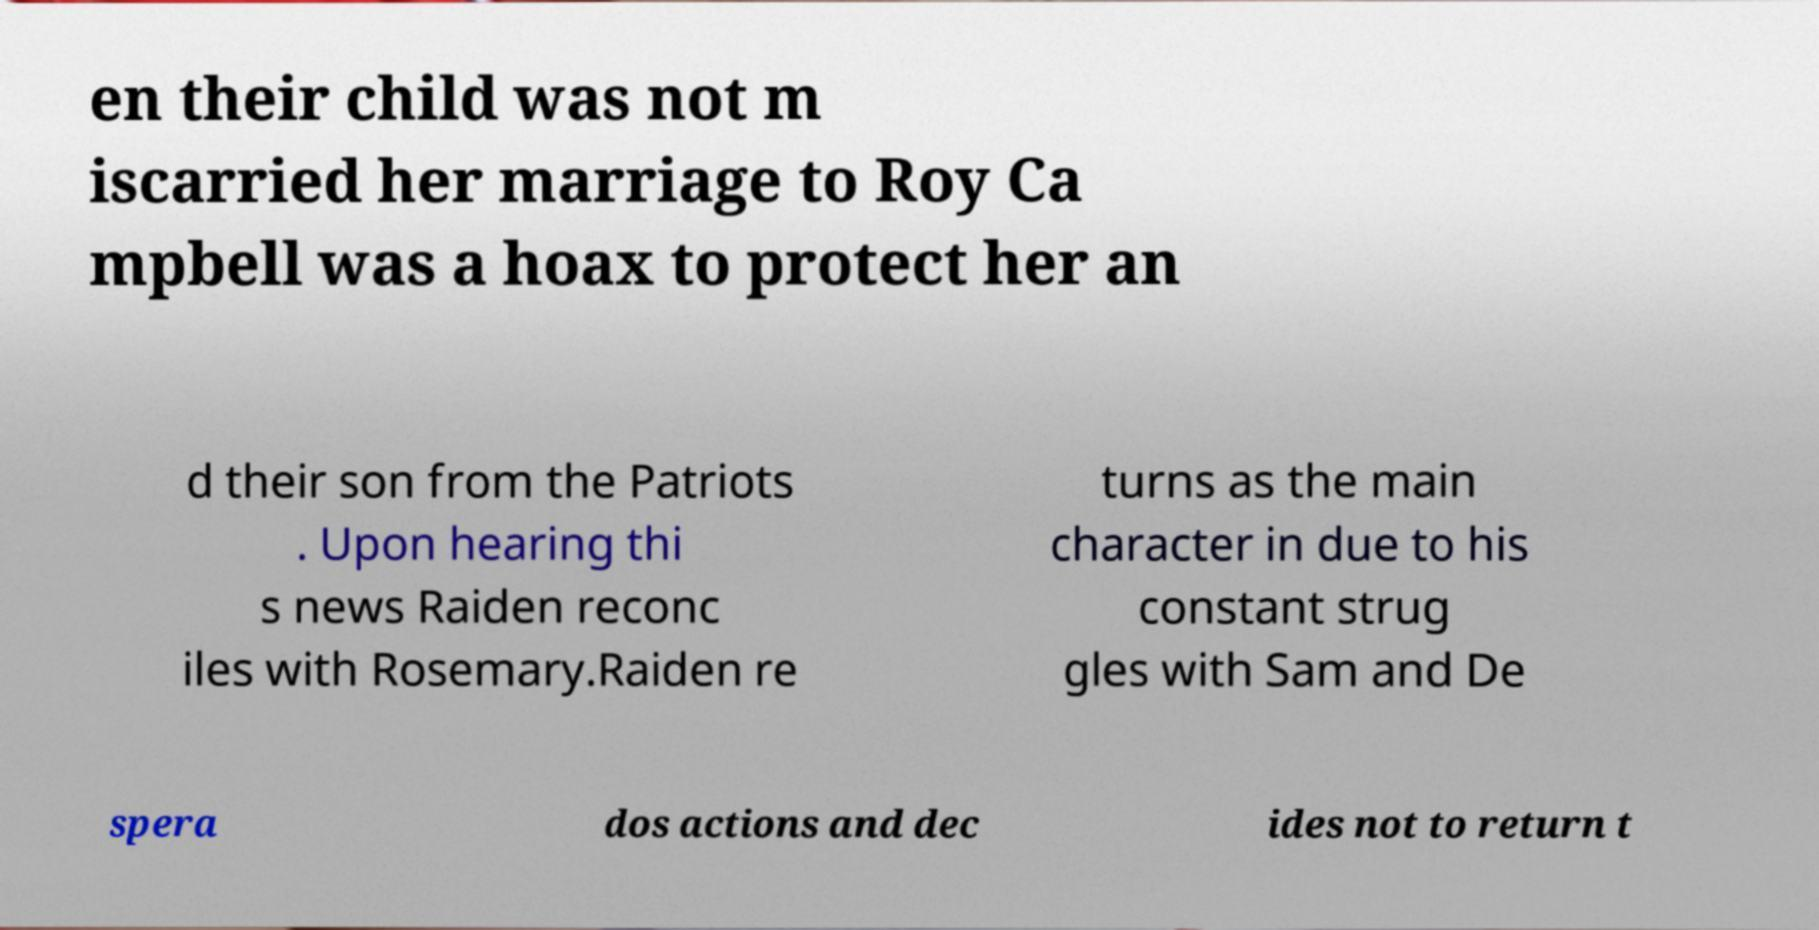Please identify and transcribe the text found in this image. en their child was not m iscarried her marriage to Roy Ca mpbell was a hoax to protect her an d their son from the Patriots . Upon hearing thi s news Raiden reconc iles with Rosemary.Raiden re turns as the main character in due to his constant strug gles with Sam and De spera dos actions and dec ides not to return t 